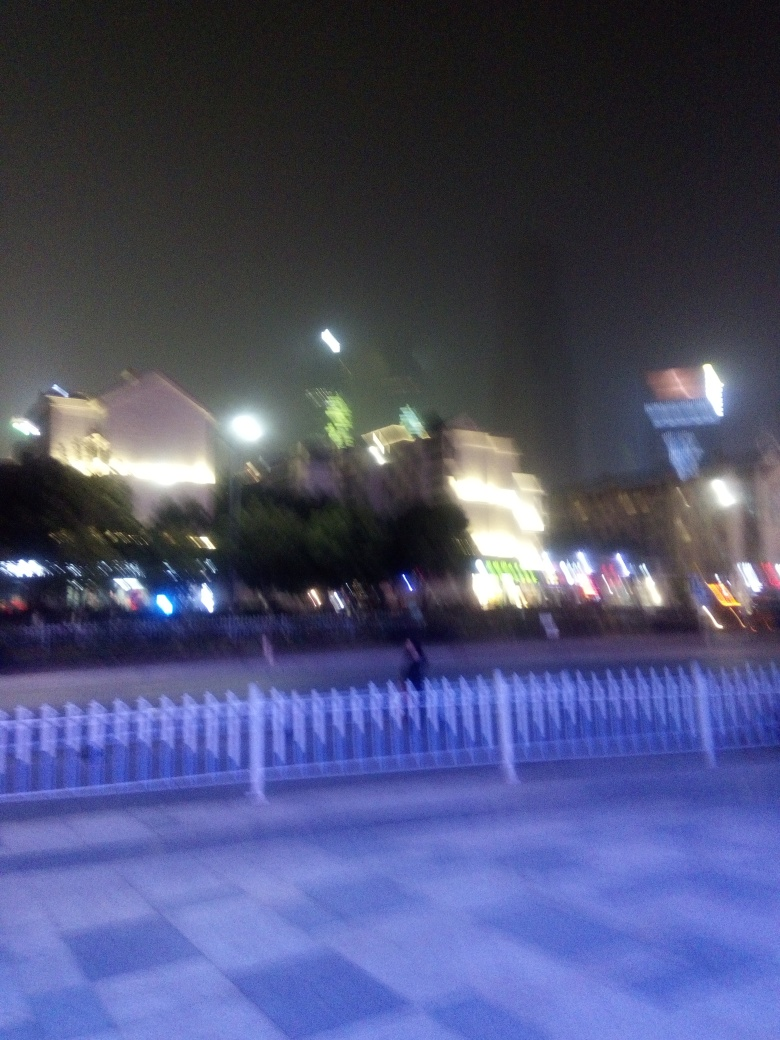Is the background blurry? Yes, the background is quite blurry. It seems to be a night scene with various light sources and buildings that are out of focus, which gives the image an impressionistic feel. 